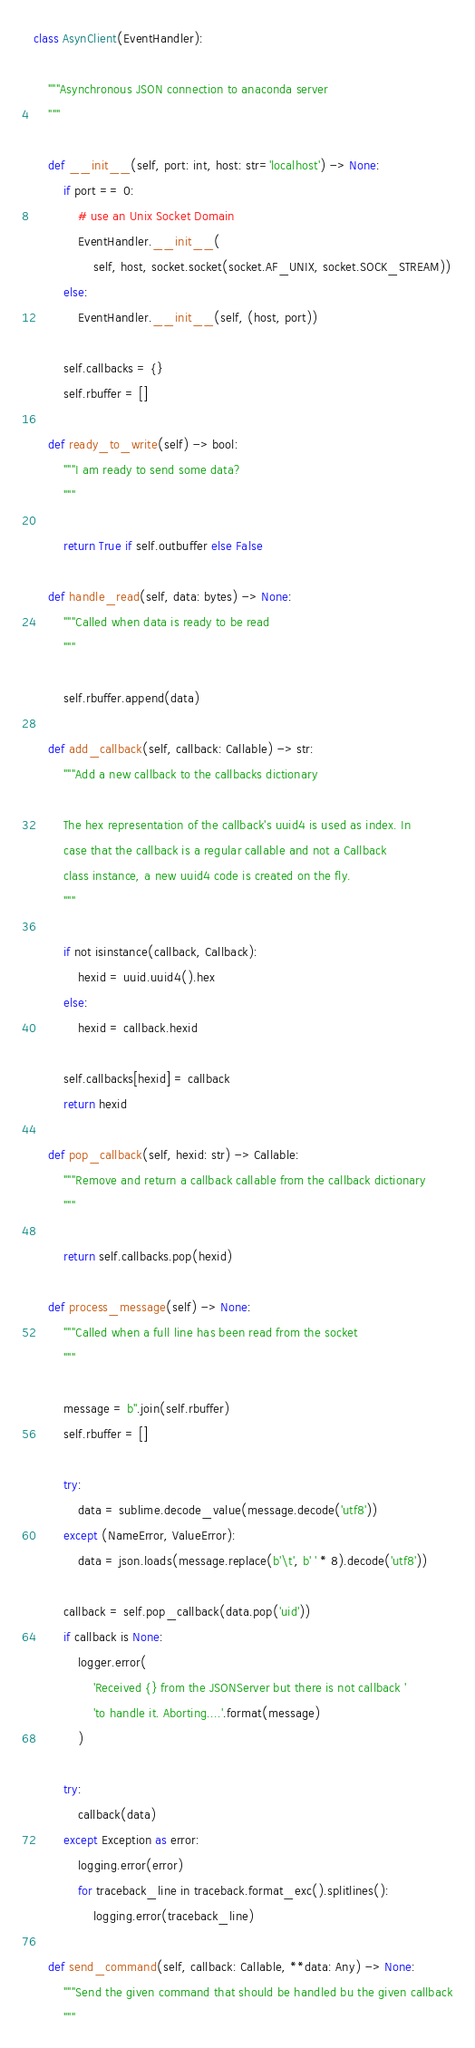<code> <loc_0><loc_0><loc_500><loc_500><_Python_>
class AsynClient(EventHandler):

    """Asynchronous JSON connection to anaconda server
    """

    def __init__(self, port: int, host: str='localhost') -> None:
        if port == 0:
            # use an Unix Socket Domain
            EventHandler.__init__(
                self, host, socket.socket(socket.AF_UNIX, socket.SOCK_STREAM))
        else:
            EventHandler.__init__(self, (host, port))

        self.callbacks = {}
        self.rbuffer = []

    def ready_to_write(self) -> bool:
        """I am ready to send some data?
        """

        return True if self.outbuffer else False

    def handle_read(self, data: bytes) -> None:
        """Called when data is ready to be read
        """

        self.rbuffer.append(data)

    def add_callback(self, callback: Callable) -> str:
        """Add a new callback to the callbacks dictionary

        The hex representation of the callback's uuid4 is used as index. In
        case that the callback is a regular callable and not a Callback
        class instance, a new uuid4 code is created on the fly.
        """

        if not isinstance(callback, Callback):
            hexid = uuid.uuid4().hex
        else:
            hexid = callback.hexid

        self.callbacks[hexid] = callback
        return hexid

    def pop_callback(self, hexid: str) -> Callable:
        """Remove and return a callback callable from the callback dictionary
        """

        return self.callbacks.pop(hexid)

    def process_message(self) -> None:
        """Called when a full line has been read from the socket
        """

        message = b''.join(self.rbuffer)
        self.rbuffer = []

        try:
            data = sublime.decode_value(message.decode('utf8'))
        except (NameError, ValueError):
            data = json.loads(message.replace(b'\t', b' ' * 8).decode('utf8'))

        callback = self.pop_callback(data.pop('uid'))
        if callback is None:
            logger.error(
                'Received {} from the JSONServer but there is not callback '
                'to handle it. Aborting....'.format(message)
            )

        try:
            callback(data)
        except Exception as error:
            logging.error(error)
            for traceback_line in traceback.format_exc().splitlines():
                logging.error(traceback_line)

    def send_command(self, callback: Callable, **data: Any) -> None:
        """Send the given command that should be handled bu the given callback
        """</code> 